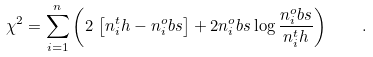<formula> <loc_0><loc_0><loc_500><loc_500>\chi ^ { 2 } = \sum _ { i = 1 } ^ { n } \left ( 2 \, \left [ n _ { i } ^ { t } h - n _ { i } ^ { o } b s \right ] + 2 n _ { i } ^ { o } b s \log \frac { n _ { i } ^ { o } b s } { n _ { i } ^ { t } h } \right ) \quad .</formula> 